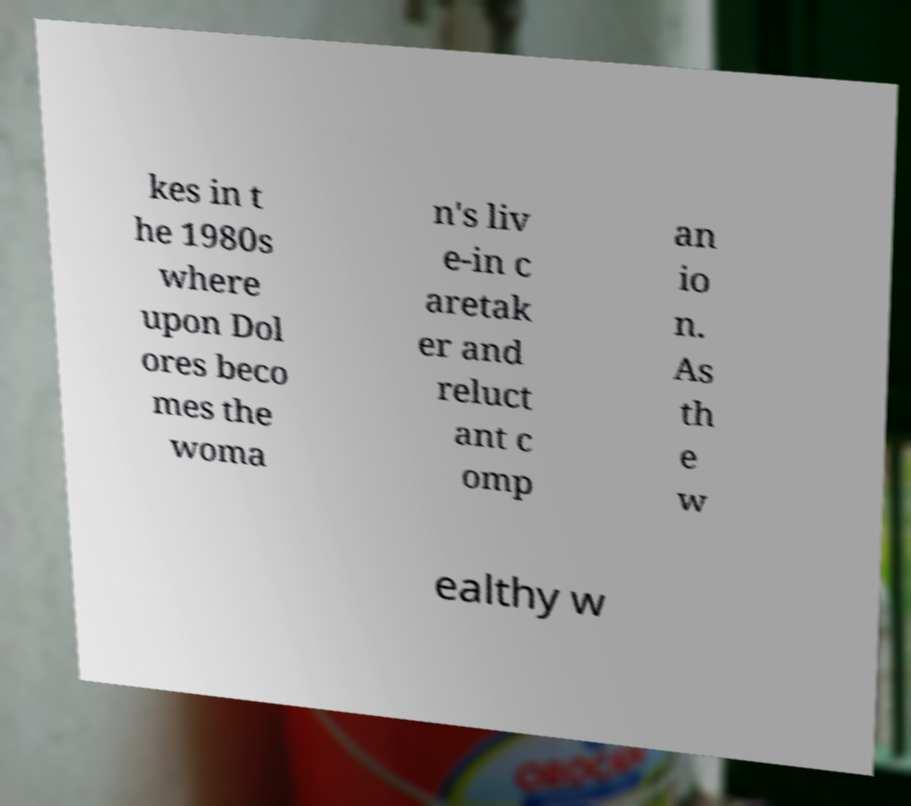Please identify and transcribe the text found in this image. kes in t he 1980s where upon Dol ores beco mes the woma n's liv e-in c aretak er and reluct ant c omp an io n. As th e w ealthy w 